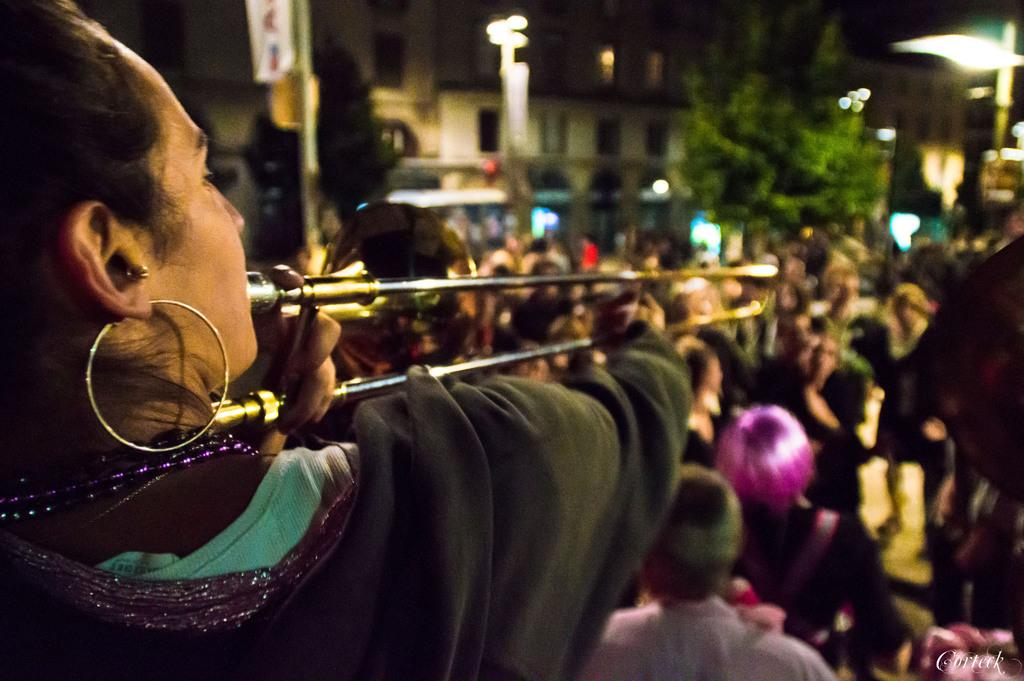What is the main activity being performed by the person in the image? There is a person playing a musical instrument in the image. Are there any other people present in the image? Yes, there are people around the person playing the musical instrument. What can be seen in the background of the image? There are buildings visible in the image. What else is present in the image besides the people and buildings? There are poles with lights and boards in the image. What type of plantation is visible in the image? There is no plantation present in the image. What color is the skirt worn by the person playing the musical instrument? The person playing the musical instrument is not wearing a skirt, so we cannot determine the color. 